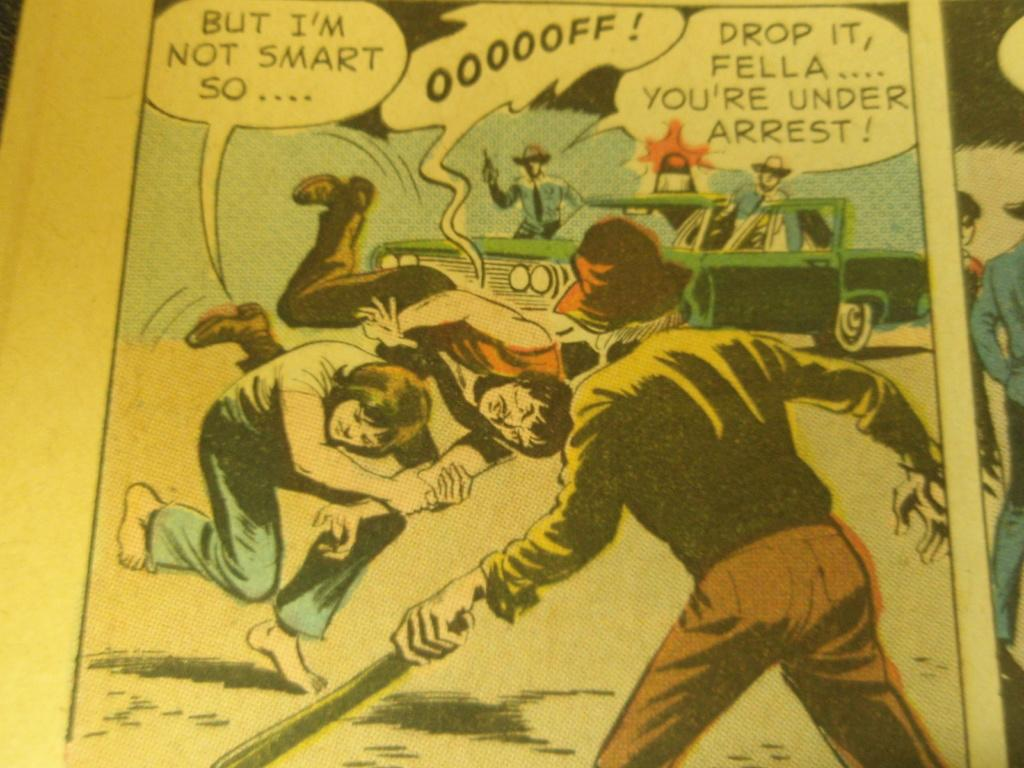<image>
Share a concise interpretation of the image provided. a comic page that says 'oooooff!' on it 